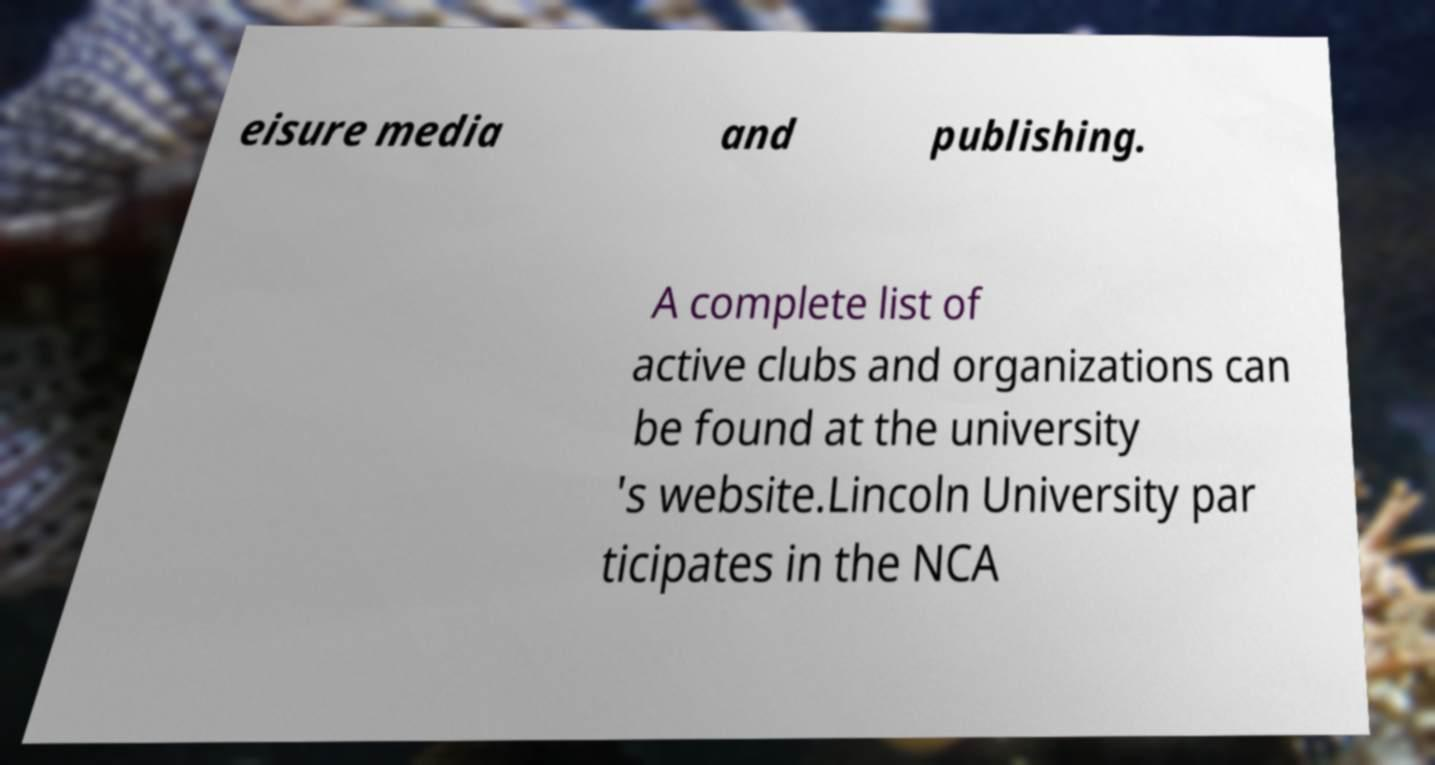Could you extract and type out the text from this image? eisure media and publishing. A complete list of active clubs and organizations can be found at the university 's website.Lincoln University par ticipates in the NCA 